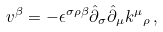<formula> <loc_0><loc_0><loc_500><loc_500>v ^ { \beta } = - \epsilon ^ { \sigma \rho \beta } \hat { \partial } _ { \sigma } \hat { \partial } _ { \mu } { k ^ { \mu } } _ { \rho } \, ,</formula> 